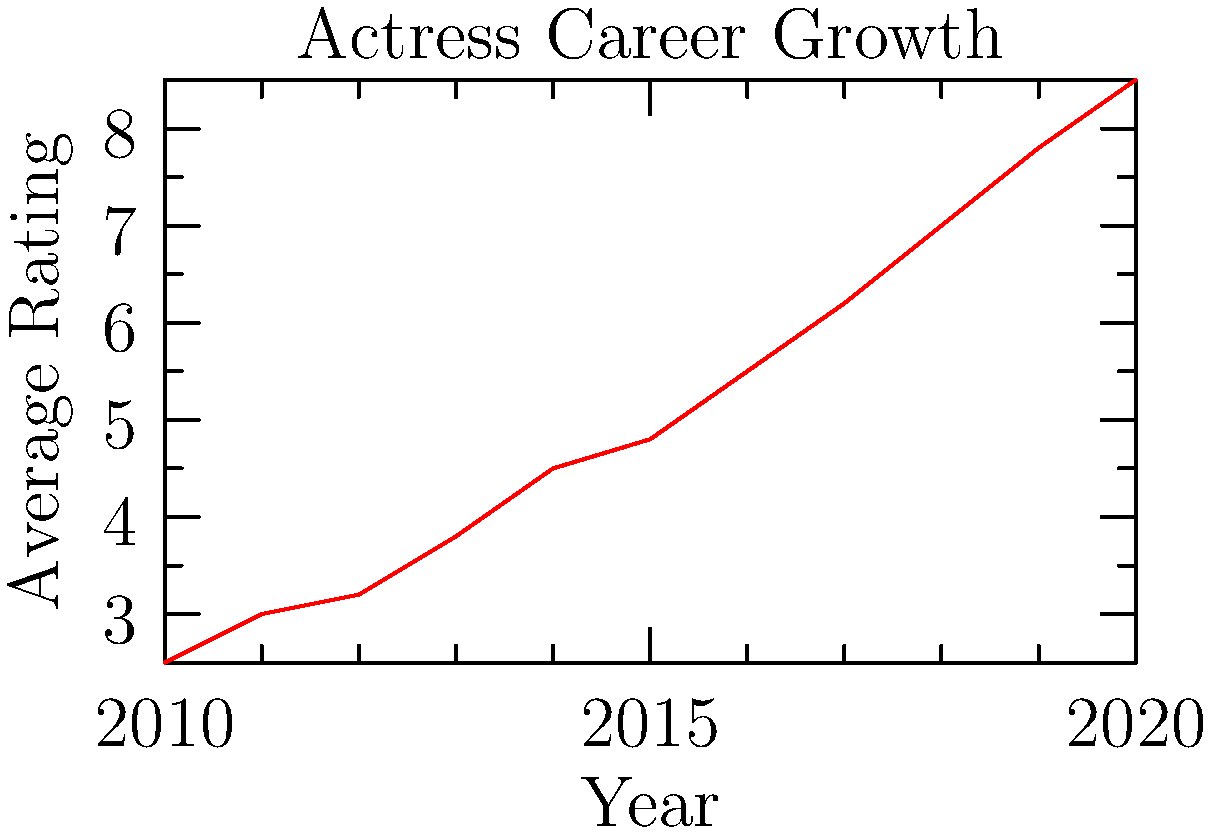Based on the line graph depicting an actress's career growth over time, what was the approximate average rating increase per year between 2010 and 2020? To calculate the average rating increase per year:

1. Identify the starting point (2010) and ending point (2020):
   - 2010 rating: 2.5
   - 2020 rating: 8.5

2. Calculate the total increase in rating:
   $8.5 - 2.5 = 6$

3. Determine the number of years:
   $2020 - 2010 = 10$ years

4. Calculate the average increase per year:
   $\frac{\text{Total increase}}{\text{Number of years}} = \frac{6}{10} = 0.6$

Therefore, the approximate average rating increase per year was 0.6.
Answer: 0.6 